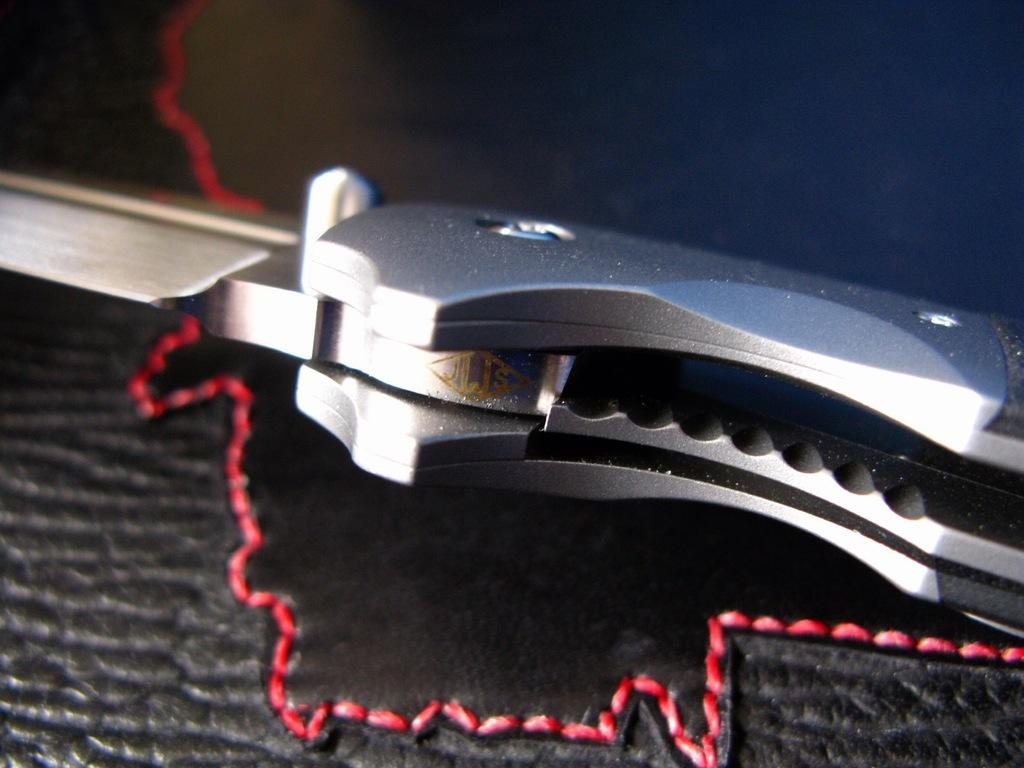What object can be seen in the image that is typically used for cutting? There is a knife in the image. What type of material and color is the sheet at the bottom of the image? The sheet at the bottom of the image is made of leather and is black in color. How many buttons can be seen on the leather sheet in the image? There are no buttons present on the leather sheet in the image. What type of activity is being performed with the knife in the image? There is no activity being performed with the knife in the image; it is simply visible. 